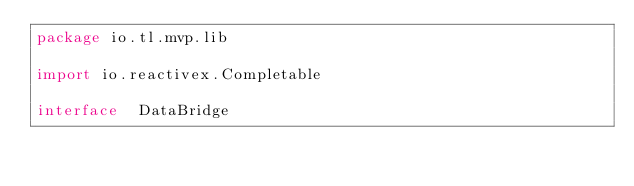Convert code to text. <code><loc_0><loc_0><loc_500><loc_500><_Kotlin_>package io.tl.mvp.lib

import io.reactivex.Completable

interface  DataBridge</code> 